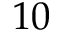Convert formula to latex. <formula><loc_0><loc_0><loc_500><loc_500>1 0</formula> 